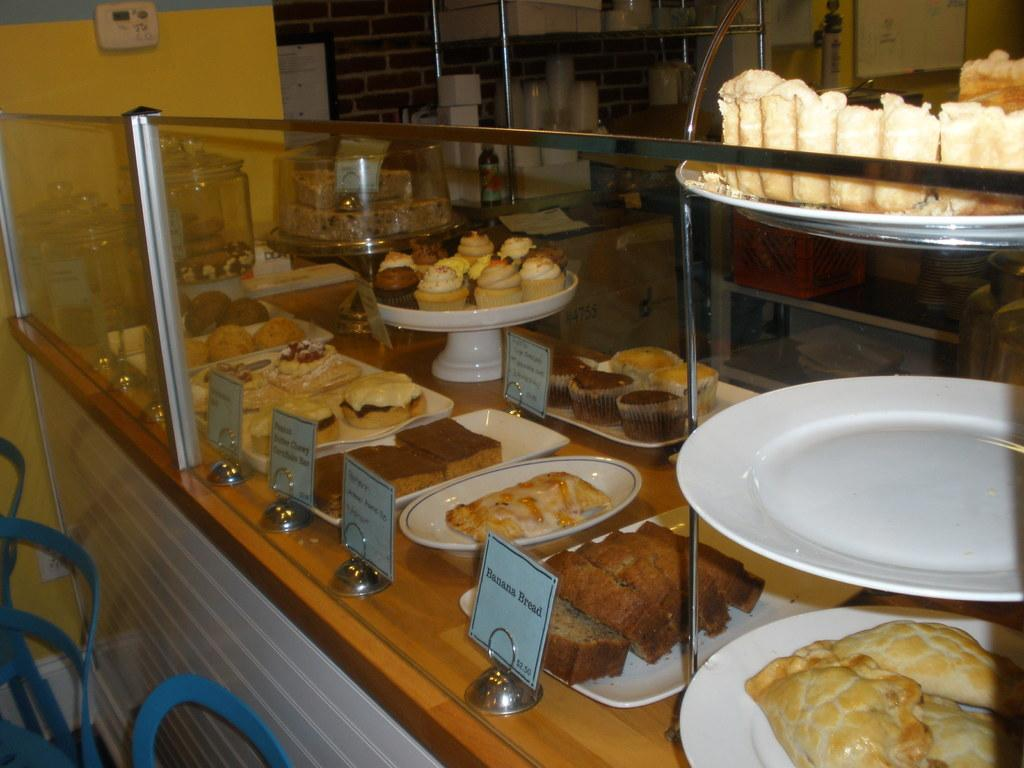What is located in the right corner of the image? There are eatables placed in the right corner of the image. Can you describe any other objects or elements in the image? There are other objects present in the background of the image. What type of laborer can be seen working in the garden in the image? There is no laborer or garden present in the image; it only shows eatables placed in the right corner and other objects in the background. 